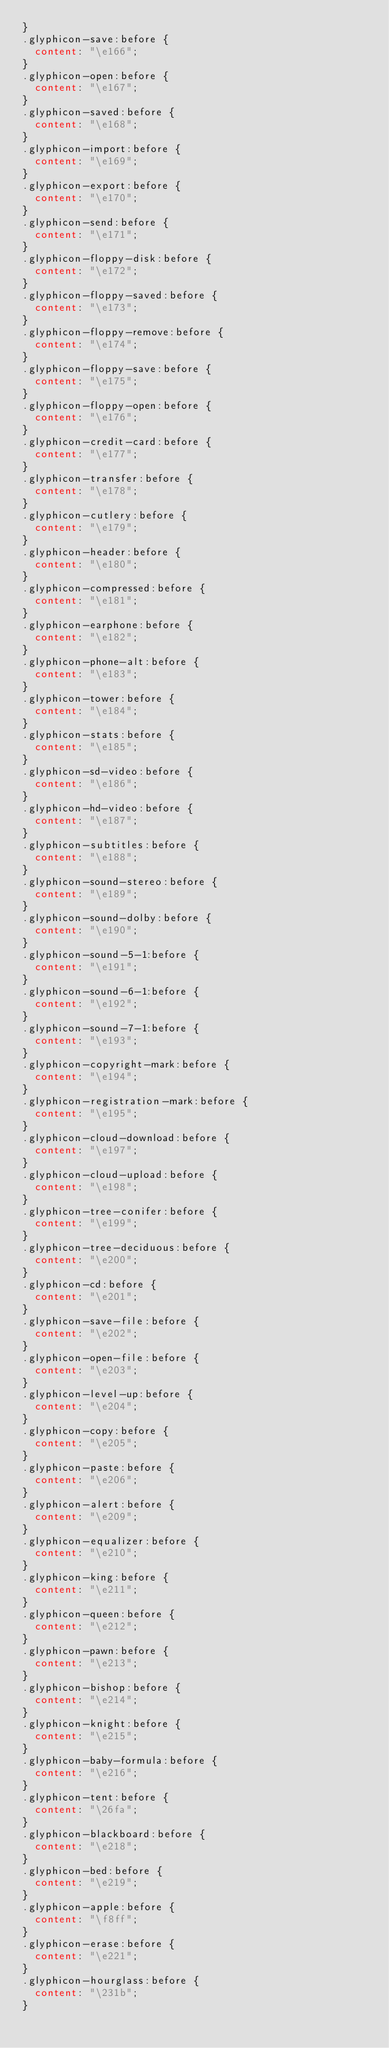Convert code to text. <code><loc_0><loc_0><loc_500><loc_500><_CSS_>}
.glyphicon-save:before {
  content: "\e166";
}
.glyphicon-open:before {
  content: "\e167";
}
.glyphicon-saved:before {
  content: "\e168";
}
.glyphicon-import:before {
  content: "\e169";
}
.glyphicon-export:before {
  content: "\e170";
}
.glyphicon-send:before {
  content: "\e171";
}
.glyphicon-floppy-disk:before {
  content: "\e172";
}
.glyphicon-floppy-saved:before {
  content: "\e173";
}
.glyphicon-floppy-remove:before {
  content: "\e174";
}
.glyphicon-floppy-save:before {
  content: "\e175";
}
.glyphicon-floppy-open:before {
  content: "\e176";
}
.glyphicon-credit-card:before {
  content: "\e177";
}
.glyphicon-transfer:before {
  content: "\e178";
}
.glyphicon-cutlery:before {
  content: "\e179";
}
.glyphicon-header:before {
  content: "\e180";
}
.glyphicon-compressed:before {
  content: "\e181";
}
.glyphicon-earphone:before {
  content: "\e182";
}
.glyphicon-phone-alt:before {
  content: "\e183";
}
.glyphicon-tower:before {
  content: "\e184";
}
.glyphicon-stats:before {
  content: "\e185";
}
.glyphicon-sd-video:before {
  content: "\e186";
}
.glyphicon-hd-video:before {
  content: "\e187";
}
.glyphicon-subtitles:before {
  content: "\e188";
}
.glyphicon-sound-stereo:before {
  content: "\e189";
}
.glyphicon-sound-dolby:before {
  content: "\e190";
}
.glyphicon-sound-5-1:before {
  content: "\e191";
}
.glyphicon-sound-6-1:before {
  content: "\e192";
}
.glyphicon-sound-7-1:before {
  content: "\e193";
}
.glyphicon-copyright-mark:before {
  content: "\e194";
}
.glyphicon-registration-mark:before {
  content: "\e195";
}
.glyphicon-cloud-download:before {
  content: "\e197";
}
.glyphicon-cloud-upload:before {
  content: "\e198";
}
.glyphicon-tree-conifer:before {
  content: "\e199";
}
.glyphicon-tree-deciduous:before {
  content: "\e200";
}
.glyphicon-cd:before {
  content: "\e201";
}
.glyphicon-save-file:before {
  content: "\e202";
}
.glyphicon-open-file:before {
  content: "\e203";
}
.glyphicon-level-up:before {
  content: "\e204";
}
.glyphicon-copy:before {
  content: "\e205";
}
.glyphicon-paste:before {
  content: "\e206";
}
.glyphicon-alert:before {
  content: "\e209";
}
.glyphicon-equalizer:before {
  content: "\e210";
}
.glyphicon-king:before {
  content: "\e211";
}
.glyphicon-queen:before {
  content: "\e212";
}
.glyphicon-pawn:before {
  content: "\e213";
}
.glyphicon-bishop:before {
  content: "\e214";
}
.glyphicon-knight:before {
  content: "\e215";
}
.glyphicon-baby-formula:before {
  content: "\e216";
}
.glyphicon-tent:before {
  content: "\26fa";
}
.glyphicon-blackboard:before {
  content: "\e218";
}
.glyphicon-bed:before {
  content: "\e219";
}
.glyphicon-apple:before {
  content: "\f8ff";
}
.glyphicon-erase:before {
  content: "\e221";
}
.glyphicon-hourglass:before {
  content: "\231b";
}</code> 